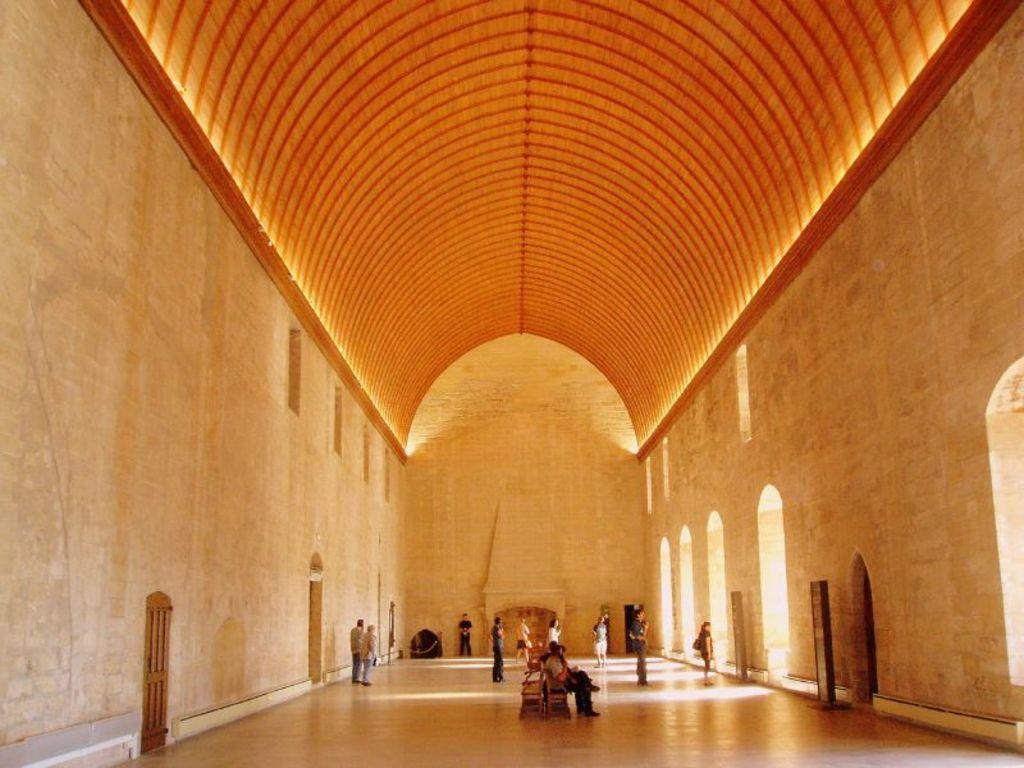Describe this image in one or two sentences. This image is clicked inside a room. In the center of the room there are people siting on the benches. Behind them there are people standing. There are doors to the wall. To the right there are arches to the wall. At the top there is a ceiling. 